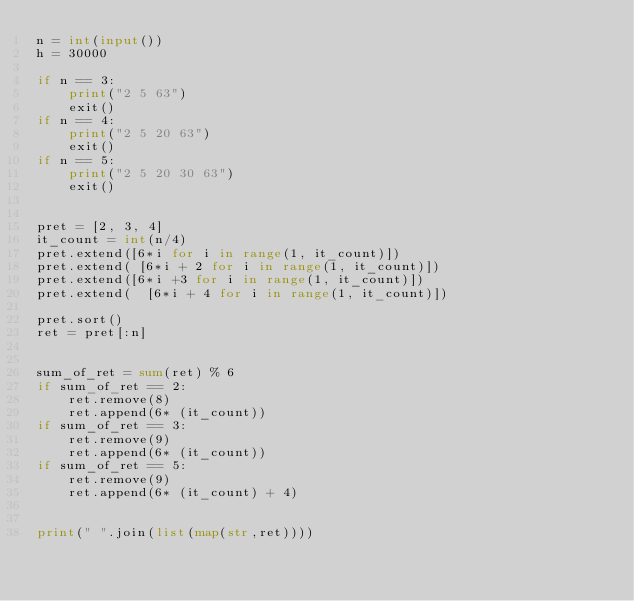<code> <loc_0><loc_0><loc_500><loc_500><_Python_>n = int(input())
h = 30000

if n == 3:
    print("2 5 63")
    exit()
if n == 4:
    print("2 5 20 63")
    exit()
if n == 5:
    print("2 5 20 30 63")
    exit()


pret = [2, 3, 4]
it_count = int(n/4)
pret.extend([6*i for i in range(1, it_count)])
pret.extend( [6*i + 2 for i in range(1, it_count)])
pret.extend([6*i +3 for i in range(1, it_count)])
pret.extend(  [6*i + 4 for i in range(1, it_count)])

pret.sort()
ret = pret[:n]


sum_of_ret = sum(ret) % 6
if sum_of_ret == 2:
    ret.remove(8)
    ret.append(6* (it_count))
if sum_of_ret == 3:
    ret.remove(9)
    ret.append(6* (it_count))
if sum_of_ret == 5:
    ret.remove(9)
    ret.append(6* (it_count) + 4)


print(" ".join(list(map(str,ret))))

</code> 